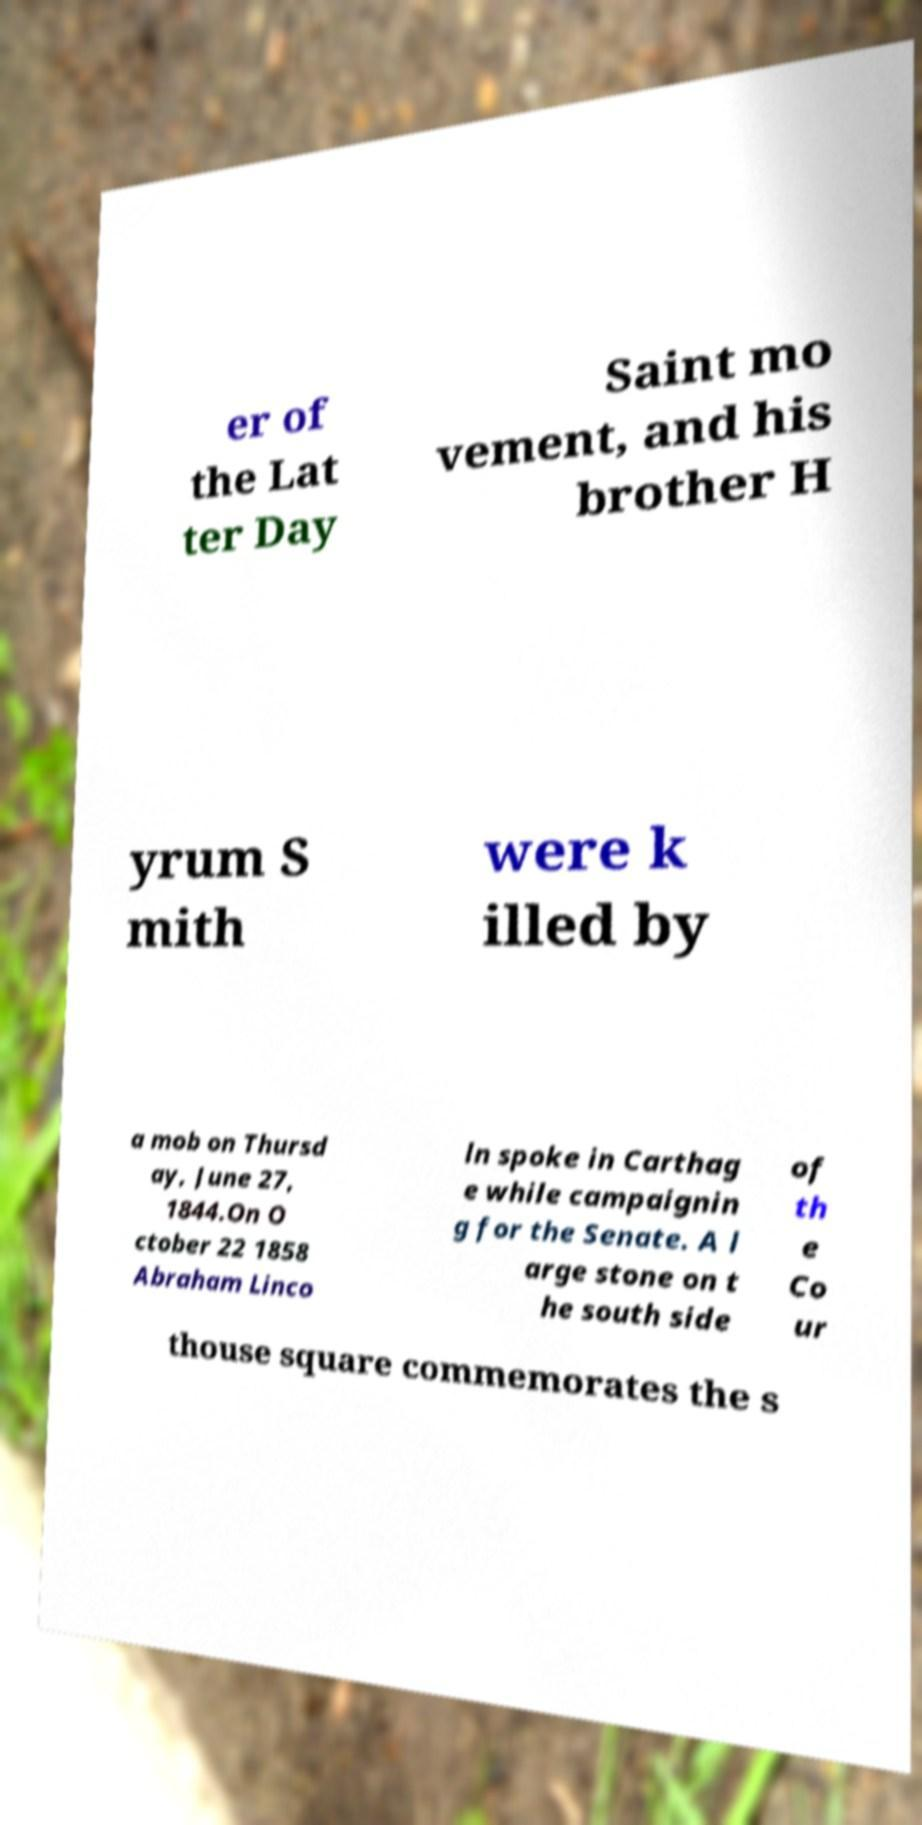For documentation purposes, I need the text within this image transcribed. Could you provide that? er of the Lat ter Day Saint mo vement, and his brother H yrum S mith were k illed by a mob on Thursd ay, June 27, 1844.On O ctober 22 1858 Abraham Linco ln spoke in Carthag e while campaignin g for the Senate. A l arge stone on t he south side of th e Co ur thouse square commemorates the s 